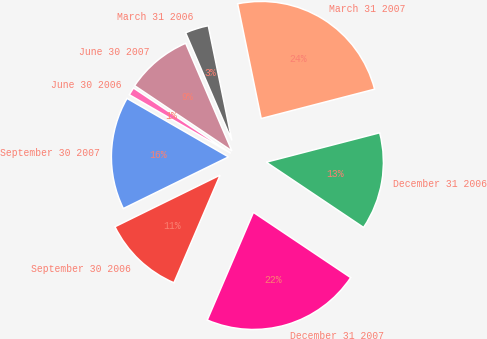Convert chart to OTSL. <chart><loc_0><loc_0><loc_500><loc_500><pie_chart><fcel>March 31 2007<fcel>March 31 2006<fcel>June 30 2007<fcel>June 30 2006<fcel>September 30 2007<fcel>September 30 2006<fcel>December 31 2007<fcel>December 31 2006<nl><fcel>24.19%<fcel>3.23%<fcel>9.14%<fcel>1.08%<fcel>15.59%<fcel>11.29%<fcel>22.04%<fcel>13.44%<nl></chart> 